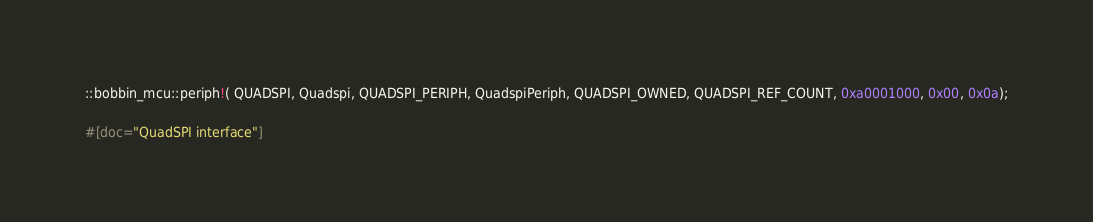<code> <loc_0><loc_0><loc_500><loc_500><_Rust_>
::bobbin_mcu::periph!( QUADSPI, Quadspi, QUADSPI_PERIPH, QuadspiPeriph, QUADSPI_OWNED, QUADSPI_REF_COUNT, 0xa0001000, 0x00, 0x0a);


#[doc="QuadSPI interface"]</code> 